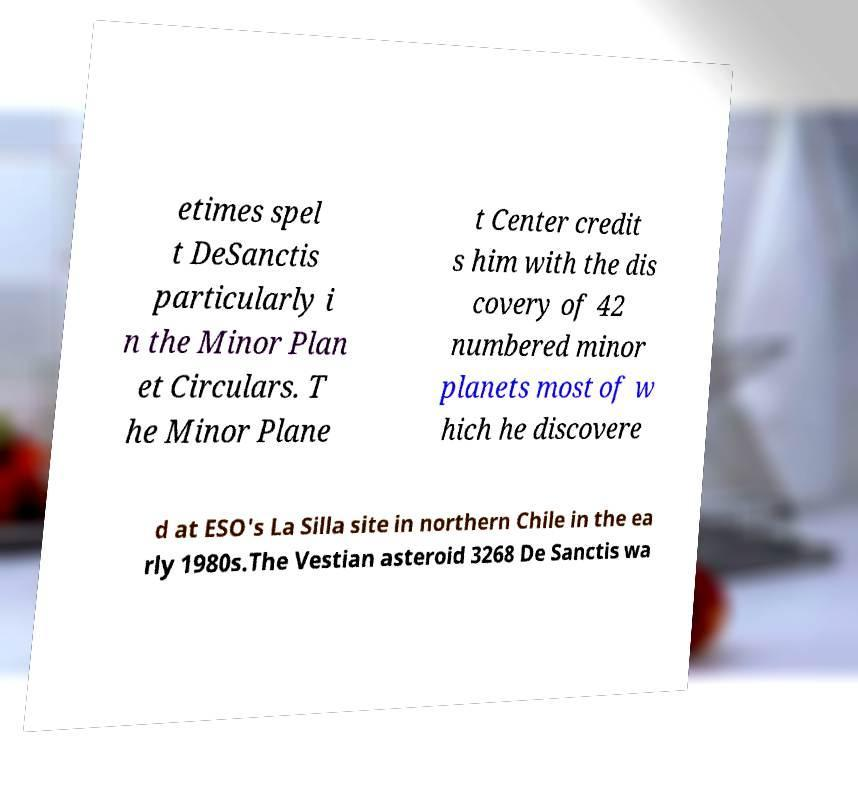I need the written content from this picture converted into text. Can you do that? etimes spel t DeSanctis particularly i n the Minor Plan et Circulars. T he Minor Plane t Center credit s him with the dis covery of 42 numbered minor planets most of w hich he discovere d at ESO's La Silla site in northern Chile in the ea rly 1980s.The Vestian asteroid 3268 De Sanctis wa 